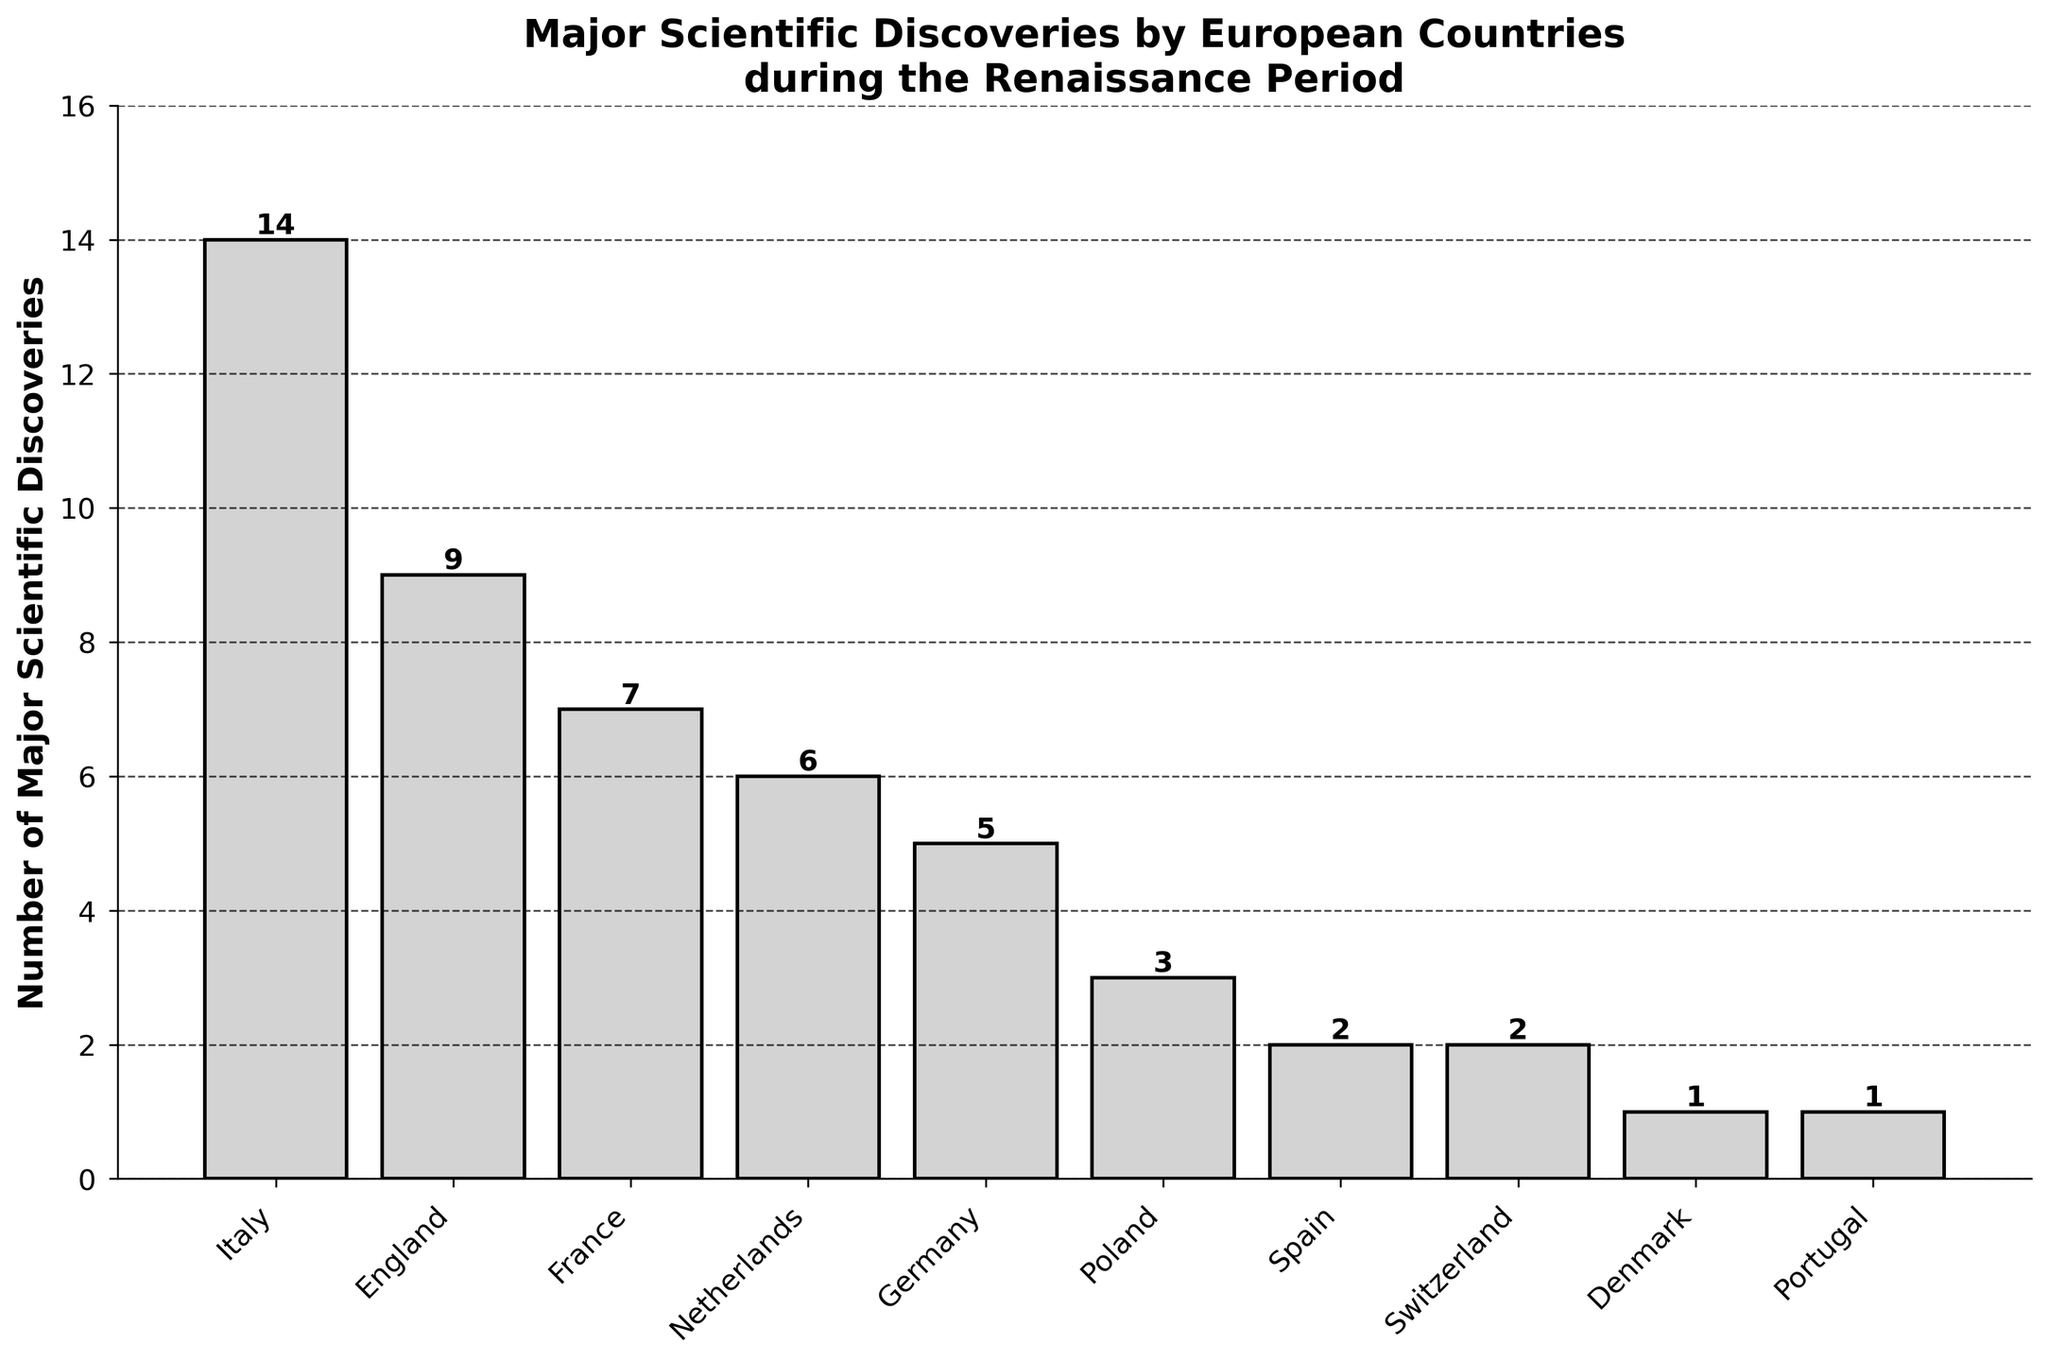Which country had the most major scientific discoveries during the Renaissance period? The figure shows a bar chart with the number of major scientific discoveries for each European country listed. Italy has the tallest bar, indicating it had the most discoveries.
Answer: Italy How many more major scientific discoveries did Italy make compared to Germany? Italy had 14 major scientific discoveries and Germany had 5. Subtracting Germany's discoveries from Italy's gives 14 - 5 = 9.
Answer: 9 Which countries made fewer than 5 major scientific discoveries? The countries with bars below the height corresponding to 5 discoveries are Poland (3), Spain (2), Switzerland (2), Denmark (1), and Portugal (1).
Answer: Poland, Spain, Switzerland, Denmark, Portugal What is the total number of major scientific discoveries made by France, Netherlands, and Poland combined? France made 7 discoveries, Netherlands 6, and Poland 3. Adding these together gives 7 + 6 + 3 = 16.
Answer: 16 How many countries made exactly 2 major scientific discoveries during the Renaissance period? The bars for Spain and Switzerland each indicate 2 major scientific discoveries. This corresponds to two countries.
Answer: 2 Which country had the fewest major scientific discoveries? The countries Denmark and Portugal each have the shortest bars indicating 1 major scientific discovery each.
Answer: Denmark, Portugal How many major scientific discoveries were made in total by all the countries? Summing the discoveries: 14 (Italy) + 9 (England) + 7 (France) + 6 (Netherlands) + 5 (Germany) + 3 (Poland) + 2 (Spain) + 2 (Switzerland) + 1 (Denmark) + 1 (Portugal) = 50.
Answer: 50 What is the difference in the number of major scientific discoveries between Spain and France? Spain had 2 discoveries and France had 7. The difference is 7 - 2 = 5.
Answer: 5 Which countries made more major scientific discoveries than England but fewer than Italy? England made 9 discoveries, and Italy made 14. Countries between these values are France with 7 discoveries and Netherlands with 6.
Answer: None What is the average number of major scientific discoveries made by Germany, Poland, and Switzerland? Germany had 5 discoveries, Poland 3, and Switzerland 2. Summing these gives 5 + 3 + 2 = 10. Dividing by 3 (number of countries) gives 10 / 3 ≈ 3.33.
Answer: 3.33 